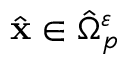<formula> <loc_0><loc_0><loc_500><loc_500>\hat { \mathbf x } \in \hat { \Omega } _ { p } ^ { \varepsilon }</formula> 